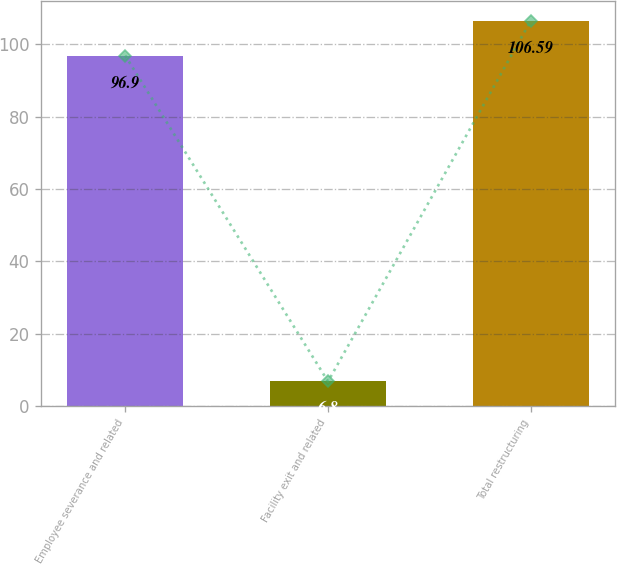<chart> <loc_0><loc_0><loc_500><loc_500><bar_chart><fcel>Employee severance and related<fcel>Facility exit and related<fcel>Total restructuring<nl><fcel>96.9<fcel>6.8<fcel>106.59<nl></chart> 